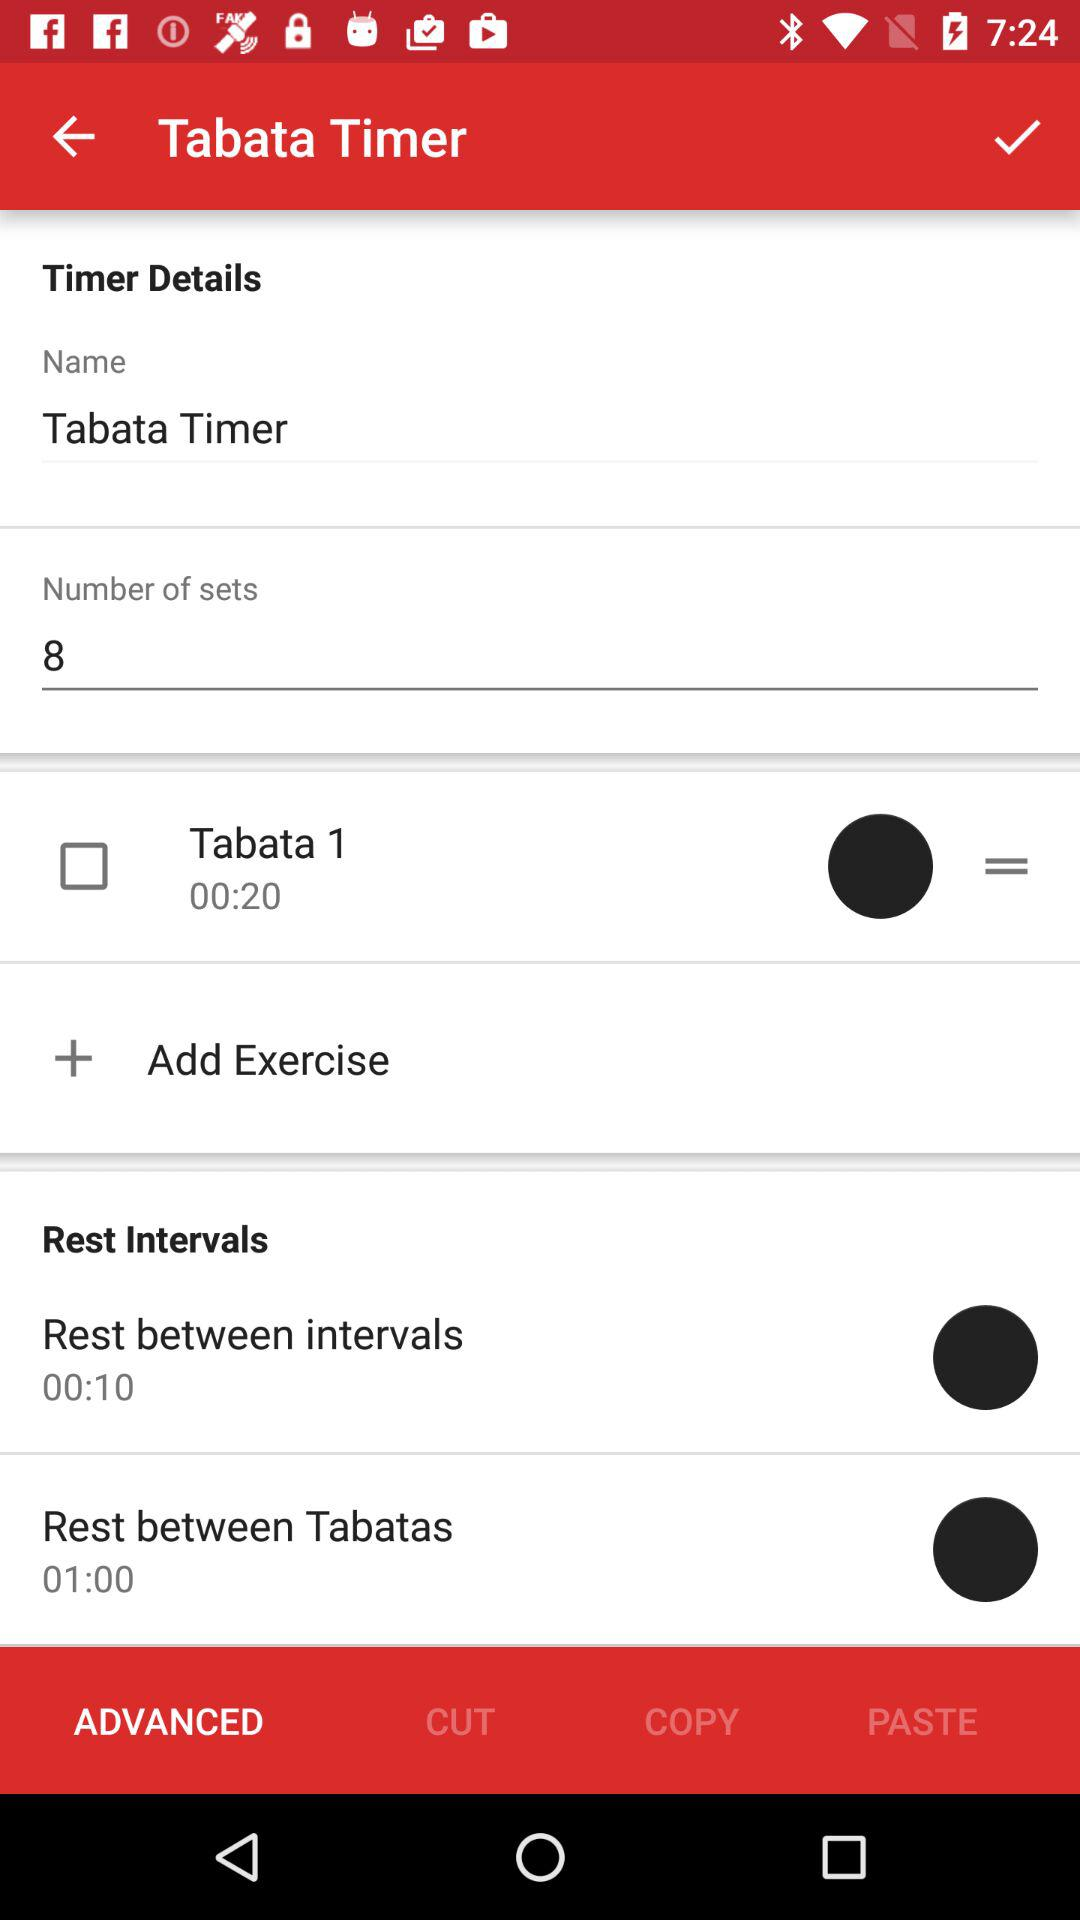How many Tabata sets are there?
Answer the question using a single word or phrase. 8 